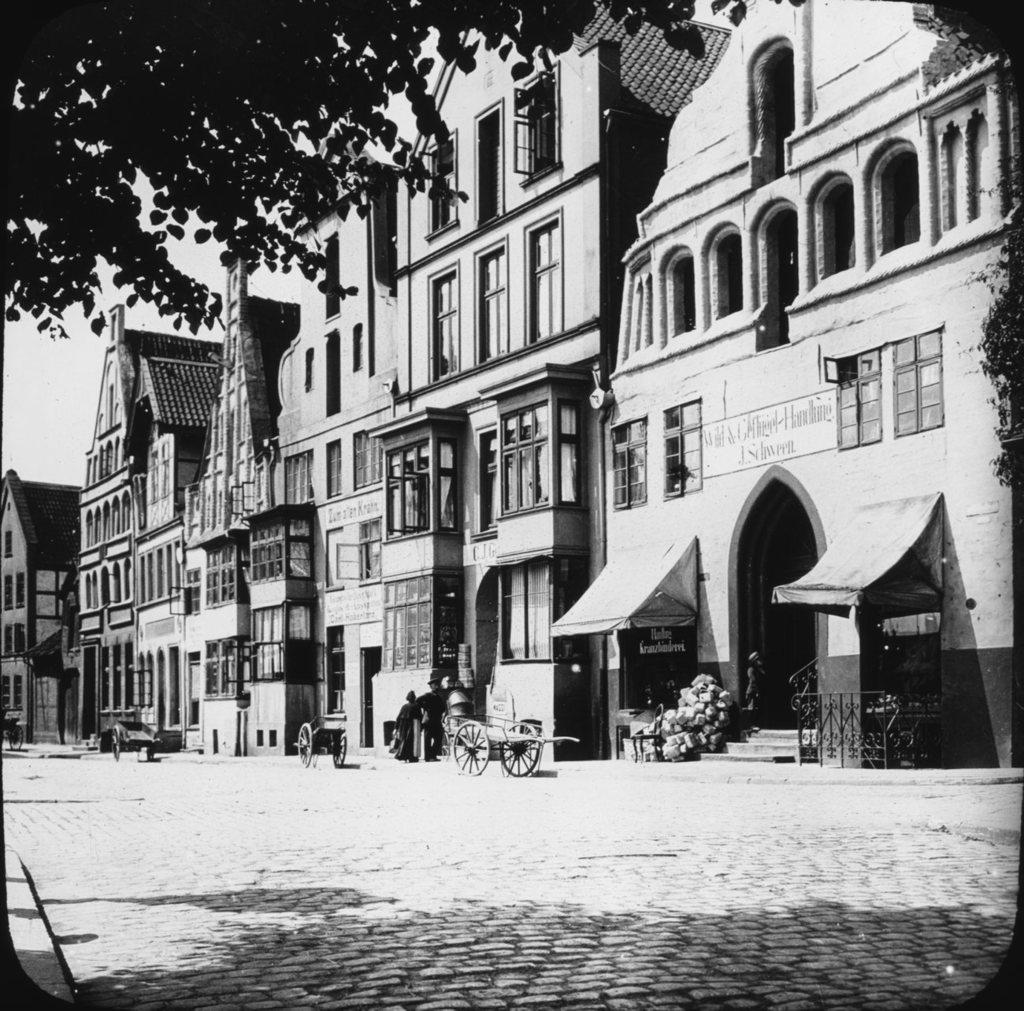What is the color scheme of the image? The image is black and white. What type of structures can be seen in the image? There are multiple buildings in the image. What is located on the road in front of the buildings? Carts are present on the road in front of the buildings. Where is the tree located in the image? There is a tree visible in the top left corner of the image. What type of work is being done by the clouds in the image? There are no clouds present in the image, so no work is being done by clouds. How many doors can be seen on the buildings in the image? There is no information about doors on the buildings in the image, so we cannot determine the number of doors. 